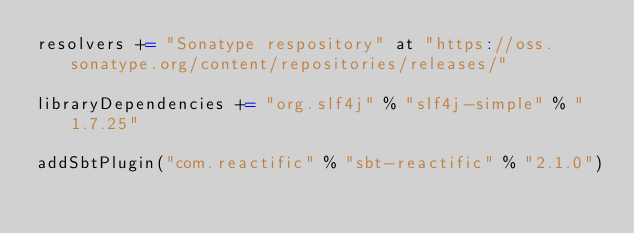Convert code to text. <code><loc_0><loc_0><loc_500><loc_500><_Scala_>resolvers += "Sonatype respository" at "https://oss.sonatype.org/content/repositories/releases/"

libraryDependencies += "org.slf4j" % "slf4j-simple" % "1.7.25"

addSbtPlugin("com.reactific" % "sbt-reactific" % "2.1.0")
</code> 